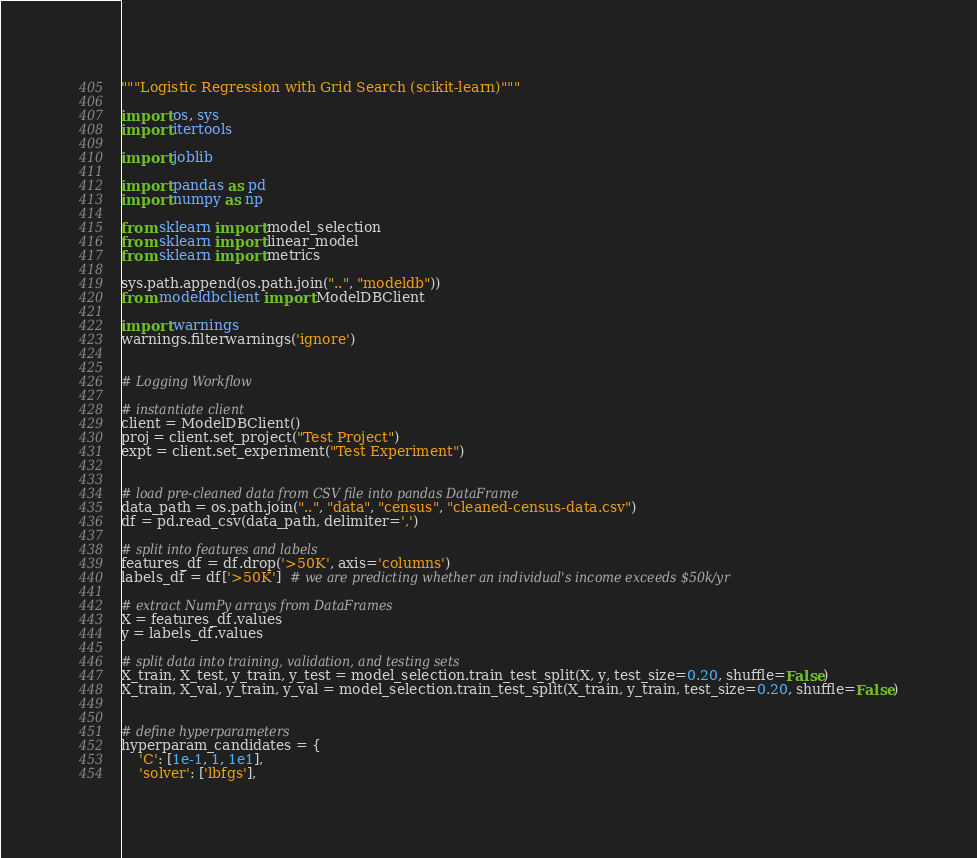<code> <loc_0><loc_0><loc_500><loc_500><_Python_>"""Logistic Regression with Grid Search (scikit-learn)"""

import os, sys
import itertools

import joblib

import pandas as pd
import numpy as np

from sklearn import model_selection
from sklearn import linear_model
from sklearn import metrics

sys.path.append(os.path.join("..", "modeldb"))
from modeldbclient import ModelDBClient

import warnings
warnings.filterwarnings('ignore')


# Logging Workflow

# instantiate client
client = ModelDBClient()
proj = client.set_project("Test Project")
expt = client.set_experiment("Test Experiment")


# load pre-cleaned data from CSV file into pandas DataFrame
data_path = os.path.join("..", "data", "census", "cleaned-census-data.csv")
df = pd.read_csv(data_path, delimiter=',')

# split into features and labels
features_df = df.drop('>50K', axis='columns')
labels_df = df['>50K']  # we are predicting whether an individual's income exceeds $50k/yr

# extract NumPy arrays from DataFrames
X = features_df.values
y = labels_df.values

# split data into training, validation, and testing sets
X_train, X_test, y_train, y_test = model_selection.train_test_split(X, y, test_size=0.20, shuffle=False)
X_train, X_val, y_train, y_val = model_selection.train_test_split(X_train, y_train, test_size=0.20, shuffle=False)


# define hyperparameters
hyperparam_candidates = {
    'C': [1e-1, 1, 1e1],
    'solver': ['lbfgs'],</code> 